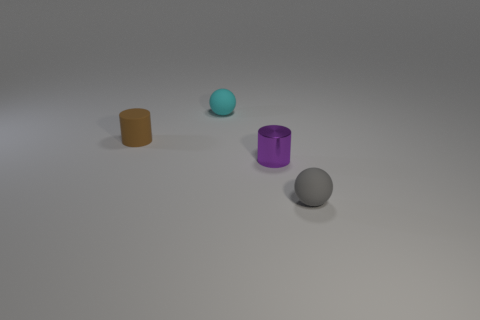What is the color of the small metallic object?
Make the answer very short. Purple. Are there any tiny cubes?
Give a very brief answer. No. There is a brown object; are there any small gray rubber balls on the left side of it?
Ensure brevity in your answer.  No. What material is the other small thing that is the same shape as the gray thing?
Provide a succinct answer. Rubber. Is there any other thing that has the same material as the cyan object?
Keep it short and to the point. Yes. How many other things are there of the same shape as the tiny cyan thing?
Your answer should be compact. 1. How many purple metal things are on the right side of the matte sphere that is in front of the small rubber ball that is behind the gray thing?
Your response must be concise. 0. What number of small green matte objects have the same shape as the tiny gray rubber thing?
Offer a terse response. 0. There is a matte ball that is on the right side of the metal object; does it have the same color as the rubber cylinder?
Offer a very short reply. No. There is a matte object that is left of the tiny cyan object that is behind the object that is left of the small cyan ball; what is its shape?
Your answer should be very brief. Cylinder. 